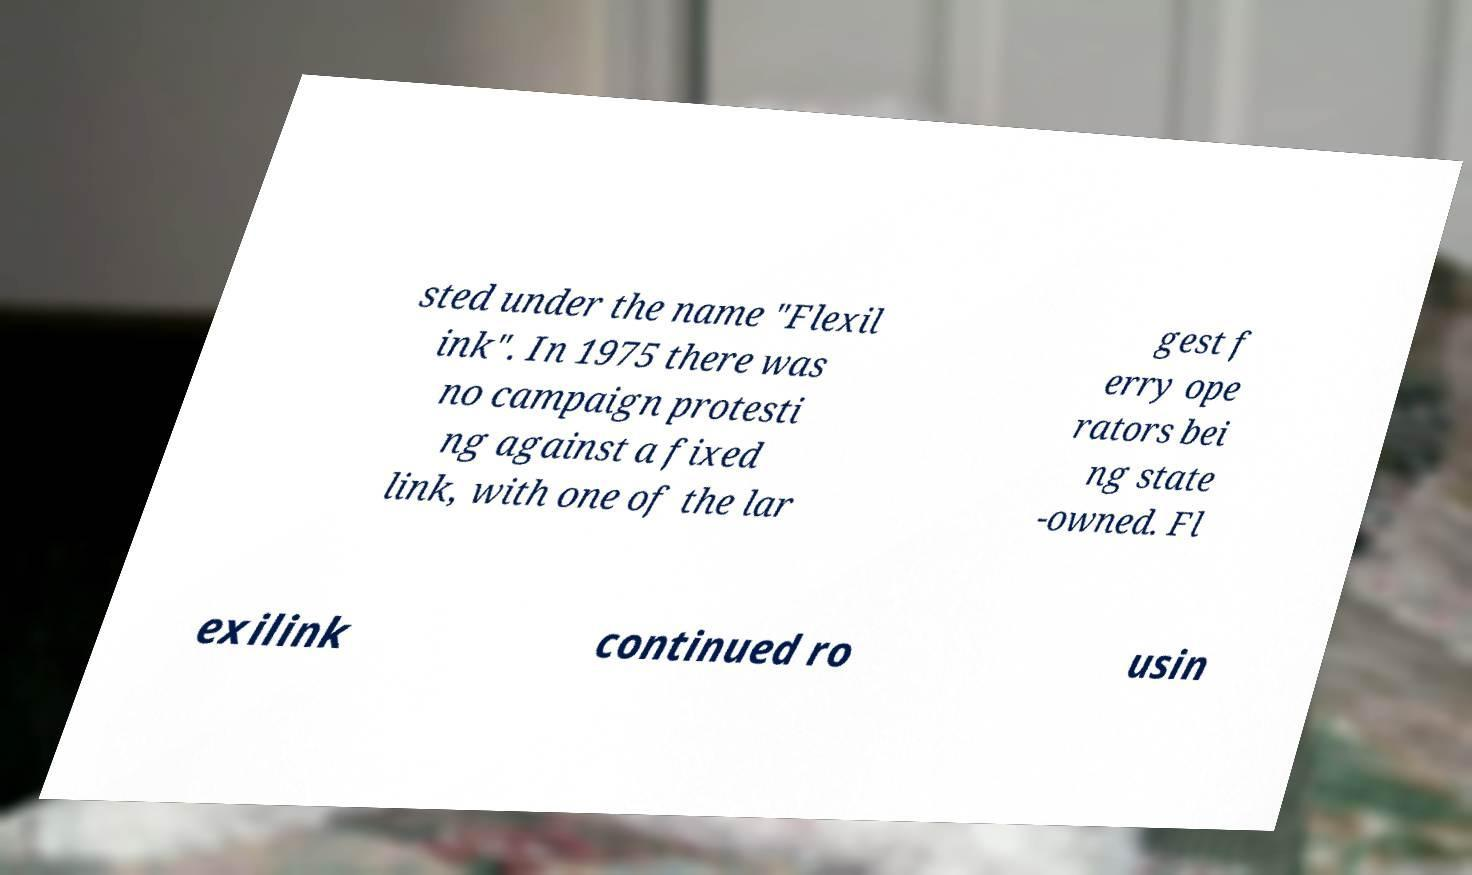For documentation purposes, I need the text within this image transcribed. Could you provide that? sted under the name "Flexil ink". In 1975 there was no campaign protesti ng against a fixed link, with one of the lar gest f erry ope rators bei ng state -owned. Fl exilink continued ro usin 